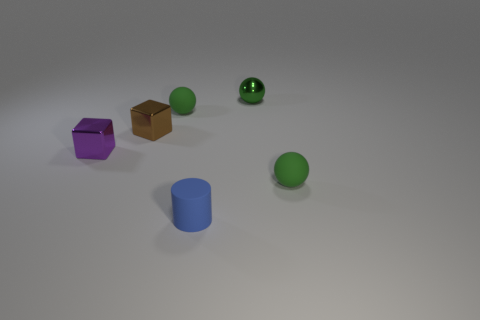Is the number of cyan rubber balls less than the number of blocks?
Provide a short and direct response. Yes. Do the matte cylinder and the matte object on the right side of the green metal object have the same color?
Your response must be concise. No. Are there the same number of shiny objects on the right side of the green metal ball and small brown shiny blocks that are to the left of the tiny purple shiny object?
Give a very brief answer. Yes. How many tiny brown shiny things have the same shape as the green metal object?
Ensure brevity in your answer.  0. Are any small cyan rubber spheres visible?
Keep it short and to the point. No. Is the material of the tiny blue cylinder the same as the sphere that is left of the small blue thing?
Make the answer very short. Yes. There is a cylinder that is the same size as the green metallic sphere; what is it made of?
Your answer should be compact. Rubber. Is there another cube made of the same material as the brown cube?
Your response must be concise. Yes. Are there any matte things that are to the left of the green rubber ball that is right of the small matte ball that is on the left side of the tiny matte cylinder?
Provide a short and direct response. Yes. There is a blue matte object that is the same size as the purple metallic object; what shape is it?
Your answer should be compact. Cylinder. 